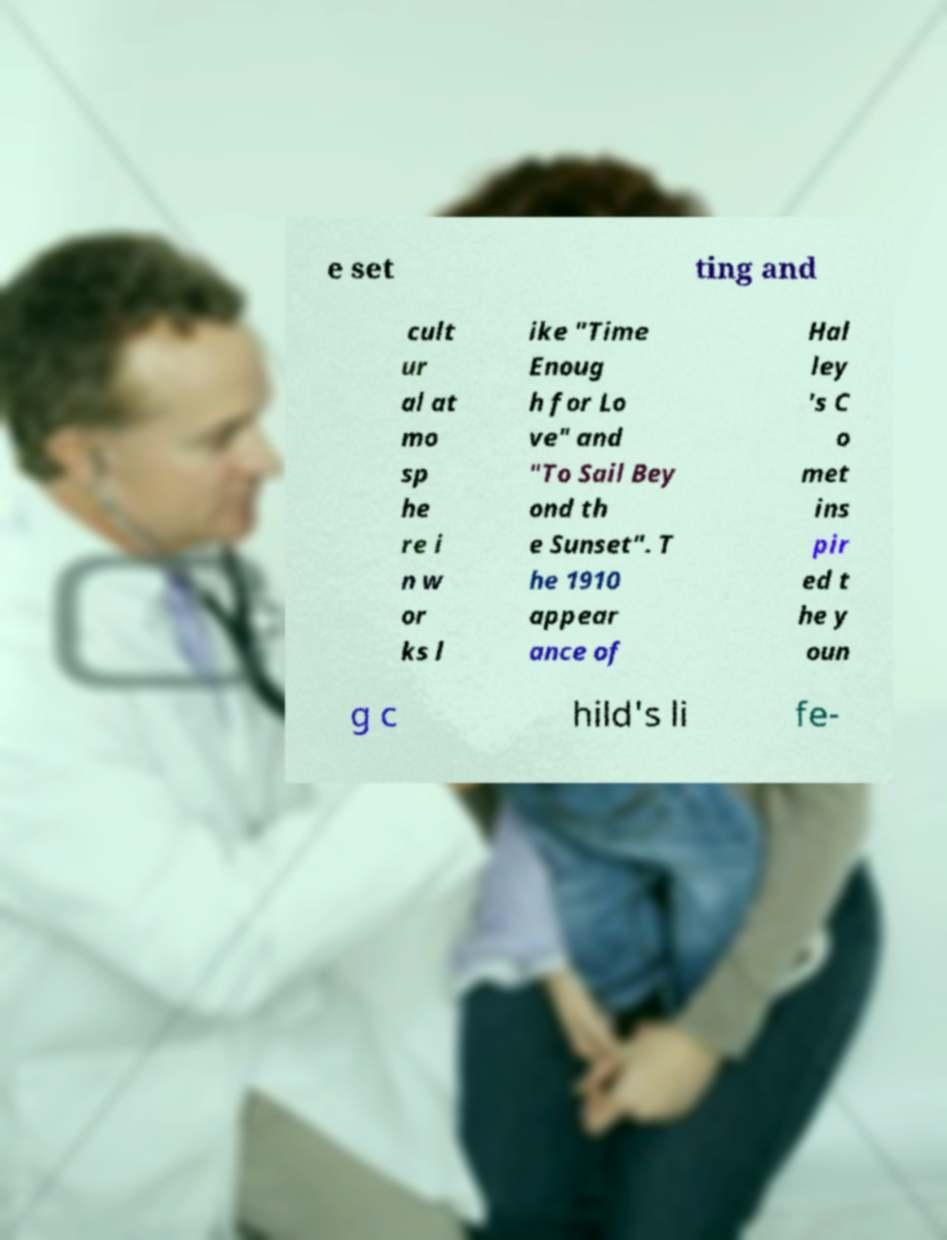Please identify and transcribe the text found in this image. e set ting and cult ur al at mo sp he re i n w or ks l ike "Time Enoug h for Lo ve" and "To Sail Bey ond th e Sunset". T he 1910 appear ance of Hal ley 's C o met ins pir ed t he y oun g c hild's li fe- 